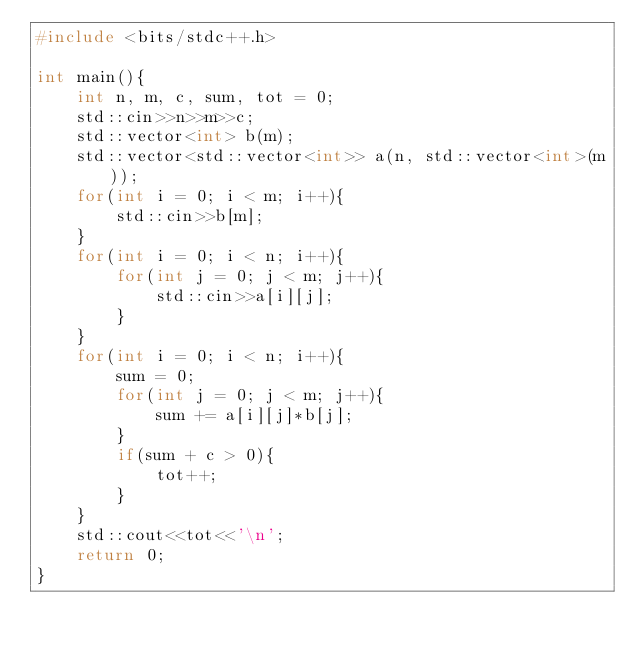<code> <loc_0><loc_0><loc_500><loc_500><_C++_>#include <bits/stdc++.h>

int main(){
    int n, m, c, sum, tot = 0;
    std::cin>>n>>m>>c;
    std::vector<int> b(m);
    std::vector<std::vector<int>> a(n, std::vector<int>(m));
    for(int i = 0; i < m; i++){
        std::cin>>b[m];
    }
    for(int i = 0; i < n; i++){
        for(int j = 0; j < m; j++){
            std::cin>>a[i][j];
        }
    }
    for(int i = 0; i < n; i++){
        sum = 0;
        for(int j = 0; j < m; j++){
            sum += a[i][j]*b[j];
        }
        if(sum + c > 0){
            tot++;
        }
    }
    std::cout<<tot<<'\n';
    return 0;
}
</code> 